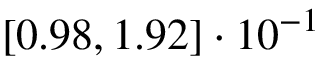<formula> <loc_0><loc_0><loc_500><loc_500>\left [ 0 . 9 8 , 1 . 9 2 \right ] \cdot 1 0 ^ { - 1 }</formula> 